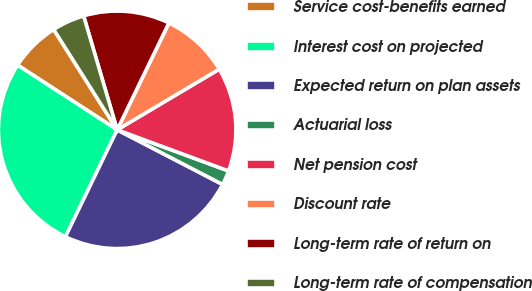Convert chart. <chart><loc_0><loc_0><loc_500><loc_500><pie_chart><fcel>Service cost-benefits earned<fcel>Interest cost on projected<fcel>Expected return on plan assets<fcel>Actuarial loss<fcel>Net pension cost<fcel>Discount rate<fcel>Long-term rate of return on<fcel>Long-term rate of compensation<nl><fcel>6.85%<fcel>27.0%<fcel>24.56%<fcel>1.98%<fcel>14.16%<fcel>9.29%<fcel>11.73%<fcel>4.42%<nl></chart> 